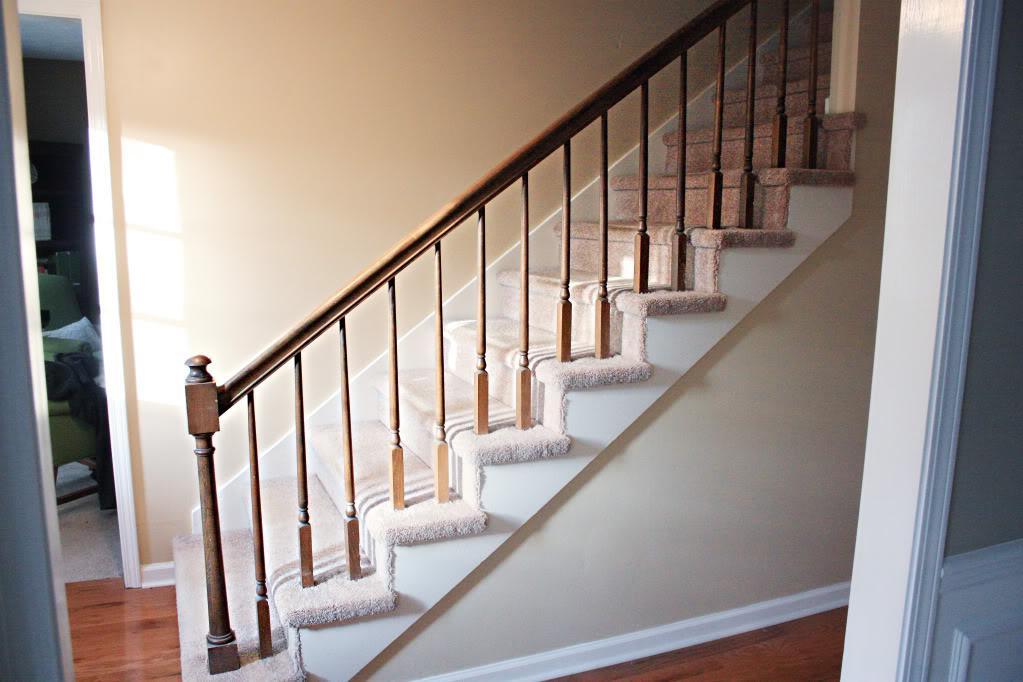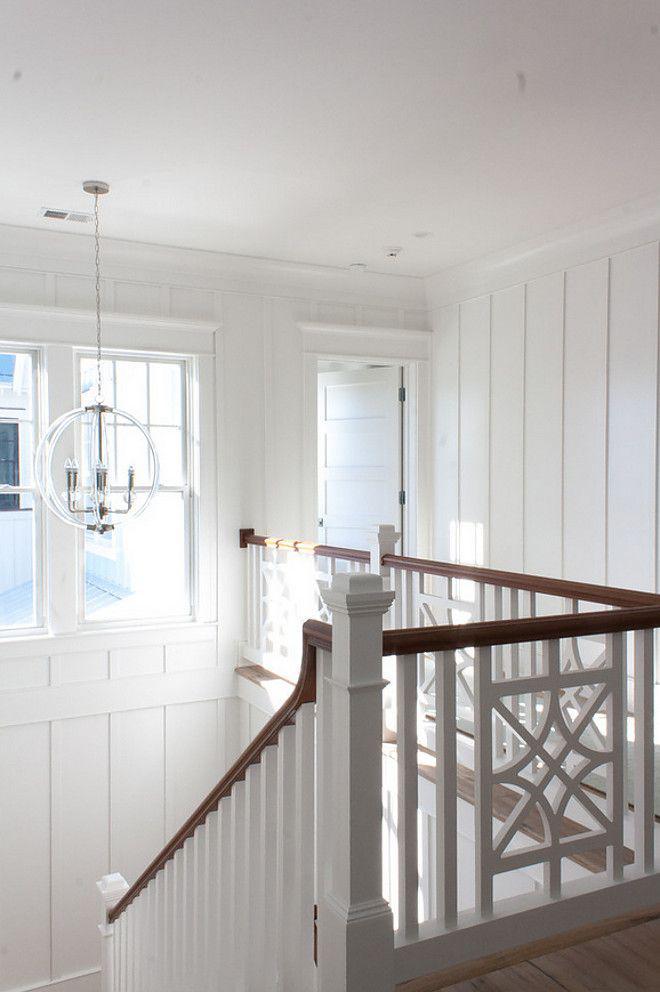The first image is the image on the left, the second image is the image on the right. Evaluate the accuracy of this statement regarding the images: "The left image shows one non-turning flight of carpeted stairs, with spindle rails and a ball atop the end post.". Is it true? Answer yes or no. Yes. The first image is the image on the left, the second image is the image on the right. Examine the images to the left and right. Is the description "there is a stairway with windows and a chandelier hanging from the ceiling" accurate? Answer yes or no. Yes. 